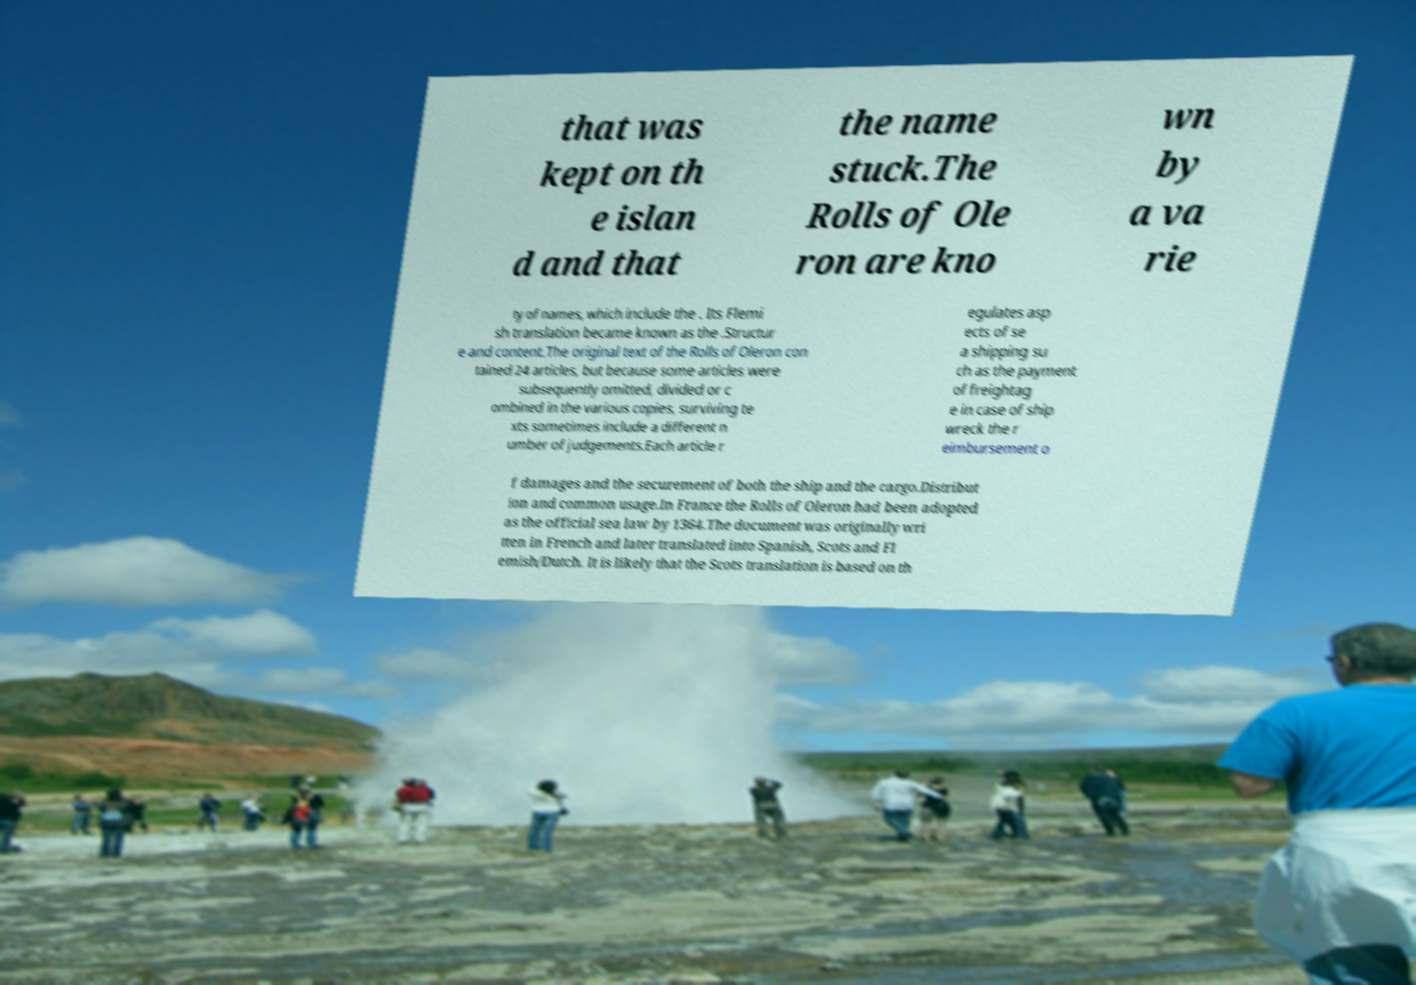Can you accurately transcribe the text from the provided image for me? that was kept on th e islan d and that the name stuck.The Rolls of Ole ron are kno wn by a va rie ty of names, which include the . Its Flemi sh translation became known as the .Structur e and content.The original text of the Rolls of Oleron con tained 24 articles, but because some articles were subsequently omitted, divided or c ombined in the various copies, surviving te xts sometimes include a different n umber of judgements.Each article r egulates asp ects of se a shipping su ch as the payment of freightag e in case of ship wreck the r eimbursement o f damages and the securement of both the ship and the cargo.Distribut ion and common usage.In France the Rolls of Oleron had been adopted as the official sea law by 1364.The document was originally wri tten in French and later translated into Spanish, Scots and Fl emish/Dutch. It is likely that the Scots translation is based on th 